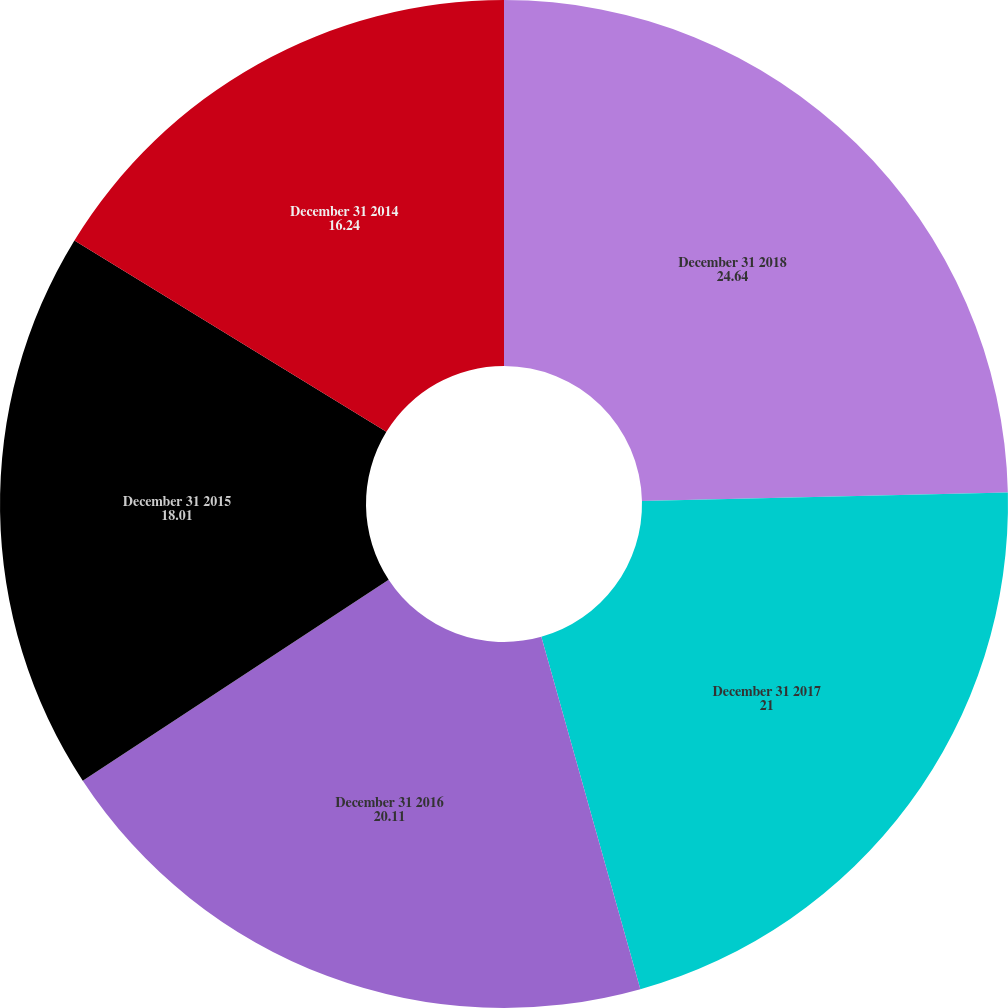Convert chart. <chart><loc_0><loc_0><loc_500><loc_500><pie_chart><fcel>December 31 2018<fcel>December 31 2017<fcel>December 31 2016<fcel>December 31 2015<fcel>December 31 2014<nl><fcel>24.64%<fcel>21.0%<fcel>20.11%<fcel>18.01%<fcel>16.24%<nl></chart> 